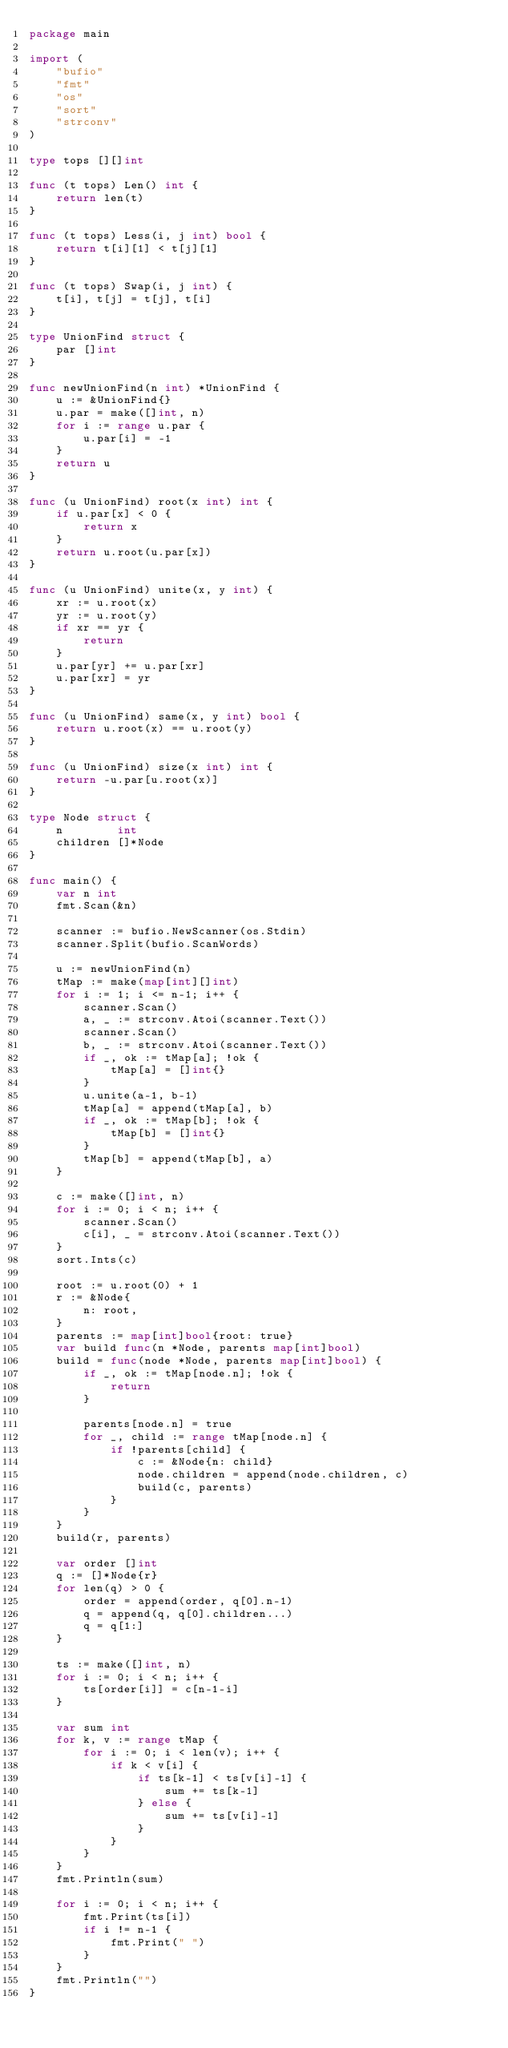<code> <loc_0><loc_0><loc_500><loc_500><_Go_>package main

import (
	"bufio"
	"fmt"
	"os"
	"sort"
	"strconv"
)

type tops [][]int

func (t tops) Len() int {
	return len(t)
}

func (t tops) Less(i, j int) bool {
	return t[i][1] < t[j][1]
}

func (t tops) Swap(i, j int) {
	t[i], t[j] = t[j], t[i]
}

type UnionFind struct {
	par []int
}

func newUnionFind(n int) *UnionFind {
	u := &UnionFind{}
	u.par = make([]int, n)
	for i := range u.par {
		u.par[i] = -1
	}
	return u
}

func (u UnionFind) root(x int) int {
	if u.par[x] < 0 {
		return x
	}
	return u.root(u.par[x])
}

func (u UnionFind) unite(x, y int) {
	xr := u.root(x)
	yr := u.root(y)
	if xr == yr {
		return
	}
	u.par[yr] += u.par[xr]
	u.par[xr] = yr
}

func (u UnionFind) same(x, y int) bool {
	return u.root(x) == u.root(y)
}

func (u UnionFind) size(x int) int {
	return -u.par[u.root(x)]
}

type Node struct {
	n        int
	children []*Node
}

func main() {
	var n int
	fmt.Scan(&n)

	scanner := bufio.NewScanner(os.Stdin)
	scanner.Split(bufio.ScanWords)

	u := newUnionFind(n)
	tMap := make(map[int][]int)
	for i := 1; i <= n-1; i++ {
		scanner.Scan()
		a, _ := strconv.Atoi(scanner.Text())
		scanner.Scan()
		b, _ := strconv.Atoi(scanner.Text())
		if _, ok := tMap[a]; !ok {
			tMap[a] = []int{}
		}
		u.unite(a-1, b-1)
		tMap[a] = append(tMap[a], b)
		if _, ok := tMap[b]; !ok {
			tMap[b] = []int{}
		}
		tMap[b] = append(tMap[b], a)
	}

	c := make([]int, n)
	for i := 0; i < n; i++ {
		scanner.Scan()
		c[i], _ = strconv.Atoi(scanner.Text())
	}
	sort.Ints(c)

	root := u.root(0) + 1
	r := &Node{
		n: root,
	}
	parents := map[int]bool{root: true}
	var build func(n *Node, parents map[int]bool)
	build = func(node *Node, parents map[int]bool) {
		if _, ok := tMap[node.n]; !ok {
			return
		}

		parents[node.n] = true
		for _, child := range tMap[node.n] {
			if !parents[child] {
				c := &Node{n: child}
				node.children = append(node.children, c)
				build(c, parents)
			}
		}
	}
	build(r, parents)

	var order []int
	q := []*Node{r}
	for len(q) > 0 {
		order = append(order, q[0].n-1)
		q = append(q, q[0].children...)
		q = q[1:]
	}

	ts := make([]int, n)
	for i := 0; i < n; i++ {
		ts[order[i]] = c[n-1-i]
	}

	var sum int
	for k, v := range tMap {
		for i := 0; i < len(v); i++ {
			if k < v[i] {
				if ts[k-1] < ts[v[i]-1] {
					sum += ts[k-1]
				} else {
					sum += ts[v[i]-1]
				}
			}
		}
	}
	fmt.Println(sum)

	for i := 0; i < n; i++ {
		fmt.Print(ts[i])
		if i != n-1 {
			fmt.Print(" ")
		}
	}
	fmt.Println("")
}
</code> 